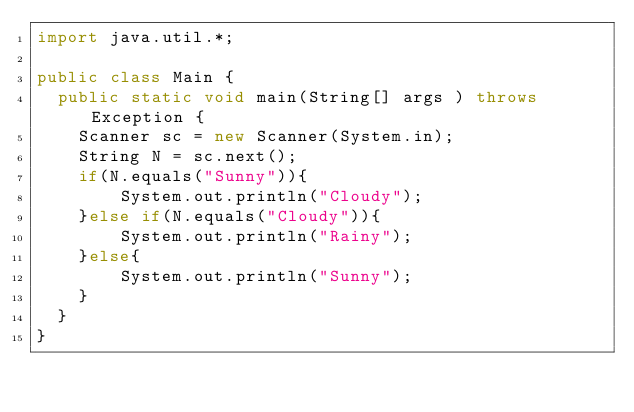<code> <loc_0><loc_0><loc_500><loc_500><_Java_>import java.util.*;

public class Main {
  public static void main(String[] args ) throws Exception {
    Scanner sc = new Scanner(System.in);
    String N = sc.next();
    if(N.equals("Sunny")){
    	System.out.println("Cloudy");
    }else if(N.equals("Cloudy")){
    	System.out.println("Rainy");
    }else{
    	System.out.println("Sunny");
    }
  }
}</code> 